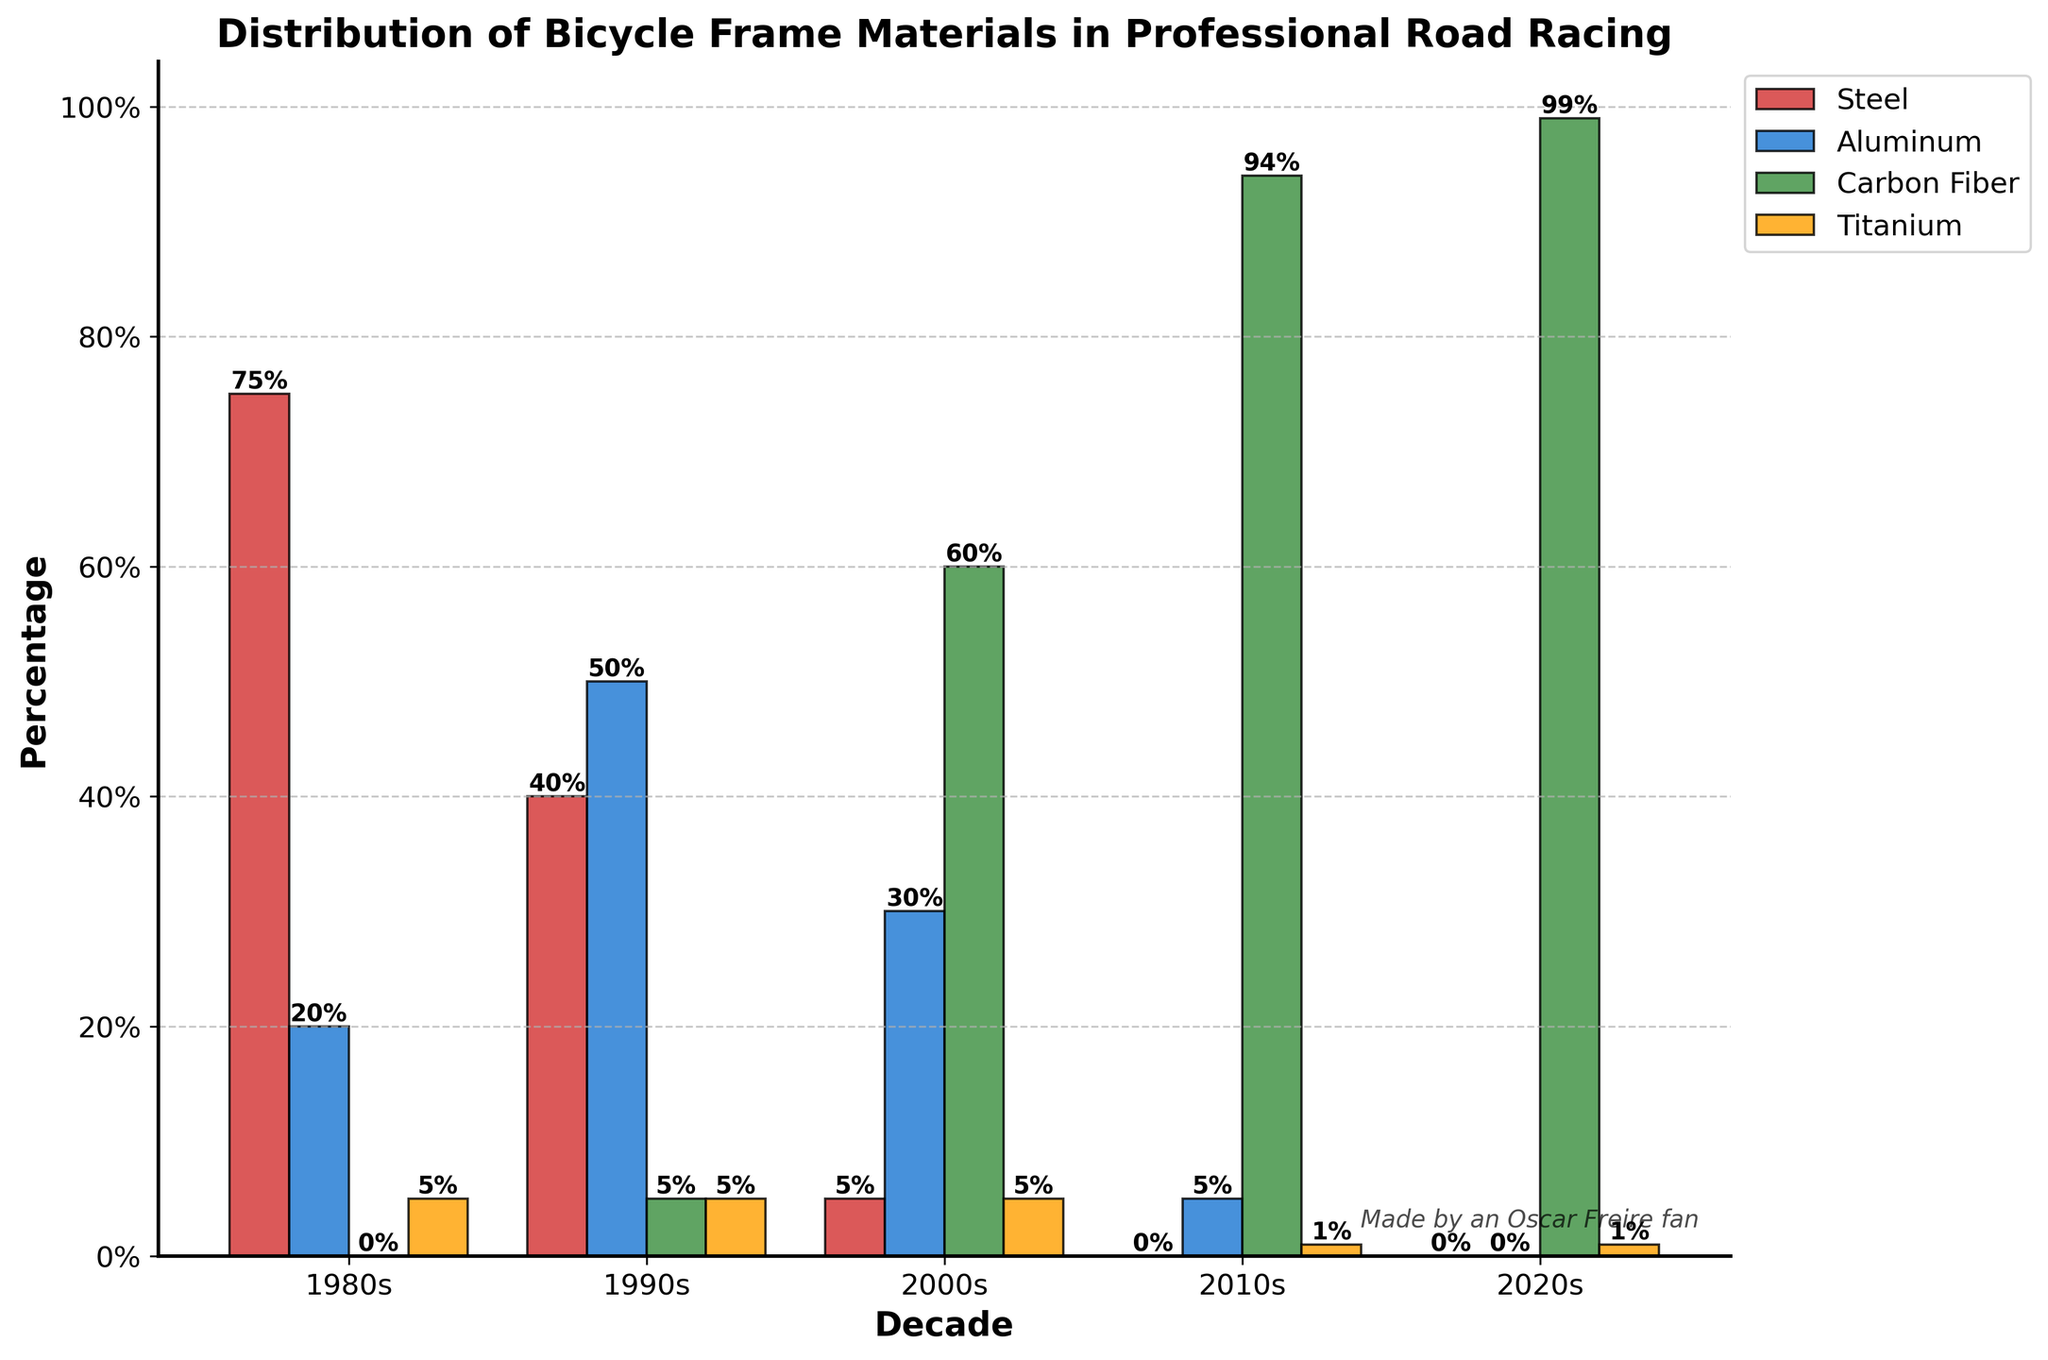What's the most common bicycle frame material in the 2010s? The tallest bar representing the 2010s decade corresponds to Carbon Fiber. The percentage for Carbon Fiber is 94, which is significantly higher than the other materials.
Answer: Carbon Fiber How has the usage of Steel changed from the 1980s to the 2020s? In the 1980s, Steel usage was 75%; in the 2020s, it dropped to 0%. The change can be calculated as 75 - 0 = 75 percentage points.
Answer: Decreased by 75 percentage points Which frame material saw the biggest increase in usage from the 1990s to the 2000s? Steel decreased from 40% to 5%, Aluminum decreased slightly from 50% to 30%, Carbon Fiber increased from 5% to 60%, and Titanium remained the same at 5%. Carbon Fiber saw the biggest increase of 55 percentage points.
Answer: Carbon Fiber If you sum the percentage use of Aluminum and Carbon Fiber in the 2000s, what do you get? In the 2000s, Aluminum usage is 30% and Carbon Fiber usage is 60%. Summing these gives 30 + 60 = 90%.
Answer: 90% Between the 1990s and the 2020s, which material had the most consistent usage percentage? Steel usage went from 40% to 0%, Aluminum from 50% to 0%, Carbon Fiber from 5% to 99%, and Titanium stayed relatively stable, moving from 5% to 1%. While all other materials either drastically dropped or increased, Titanium had the smallest change of 4 percentage points.
Answer: Titanium What frame material had the least representation in the 1980s? In the 1980s, Carbon Fiber had 0% usage, which is the lowest compared to Steel (75%), Aluminum (20%), and Titanium (5%).
Answer: Carbon Fiber Compare the change in the usage of Aluminum from the 1980s to the 2010s. How does it differ? Aluminum usage in the 1980s was 20% and dropped to 5% in the 2010s. The change can be calculated as 20 - 5 = 15 percentage points.
Answer: Decreased by 15 percentage points What can you infer about the usage trend of Carbon Fiber over the decades? Carbon Fiber usage starts at 0% in the 1980s, increases to 5% in the 1990s, jumps to 60% in the 2000s, rises significantly to 94% in the 2010s, and reaches 99% in the 2020s. The trend shows a dramatic and consistent increase over the decades.
Answer: Increasing trend Which decade showed the highest diversity in the usage of bicycle frame materials? The 1990s show a relatively even distribution with Steel at 40%, Aluminum at 50%, Carbon Fiber at 5%, and Titanium at 5%. This means no single material overly dominates the rest.
Answer: 1990s How much did the usage of Titanium change from the 1980s to the 2000s? Titanium's usage in the 1980s was 5%, and it remained at 5% in the 2000s. The change is 5 - 5 = 0 percentage points, showing no change.
Answer: No change 